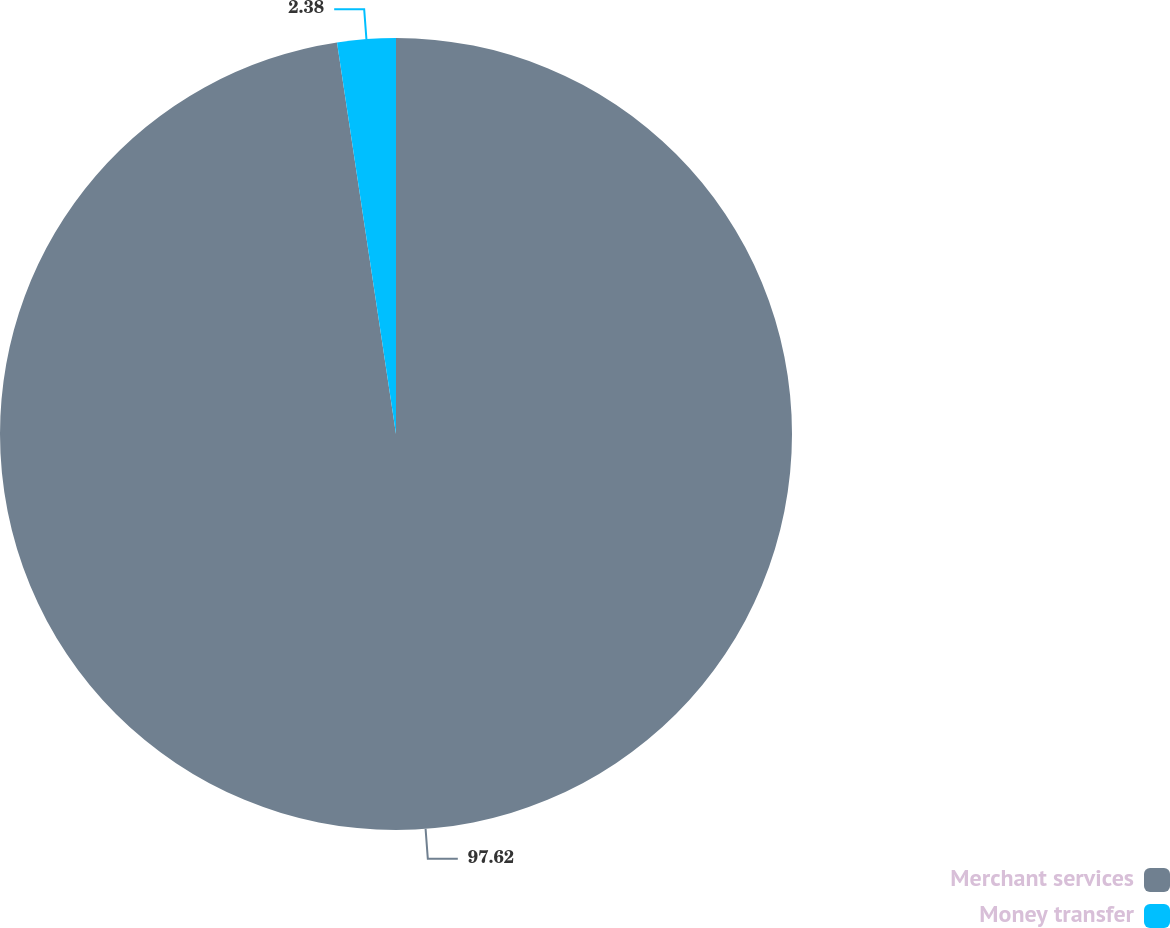Convert chart to OTSL. <chart><loc_0><loc_0><loc_500><loc_500><pie_chart><fcel>Merchant services<fcel>Money transfer<nl><fcel>97.62%<fcel>2.38%<nl></chart> 